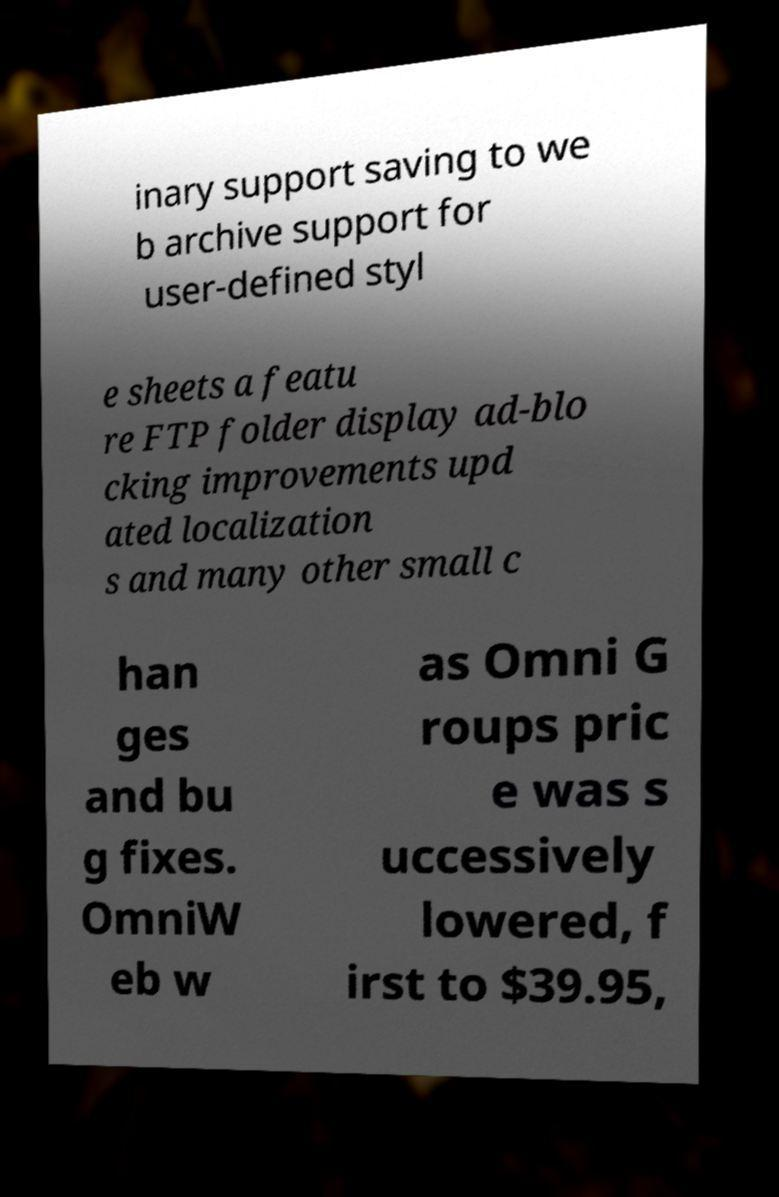There's text embedded in this image that I need extracted. Can you transcribe it verbatim? inary support saving to we b archive support for user-defined styl e sheets a featu re FTP folder display ad-blo cking improvements upd ated localization s and many other small c han ges and bu g fixes. OmniW eb w as Omni G roups pric e was s uccessively lowered, f irst to $39.95, 